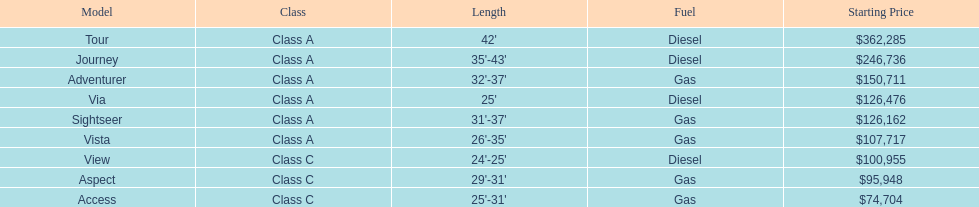Which model is at the top of the list with the maximum opening price? Tour. 